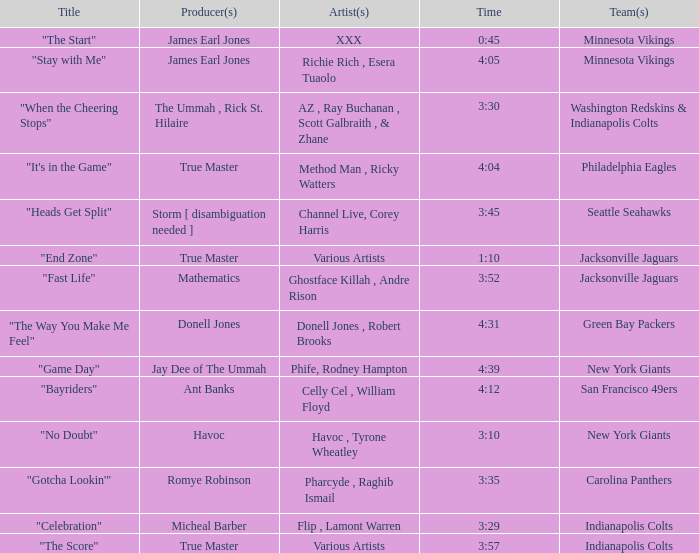Who created the "no doubt" track for the new york giants? Havoc , Tyrone Wheatley. 